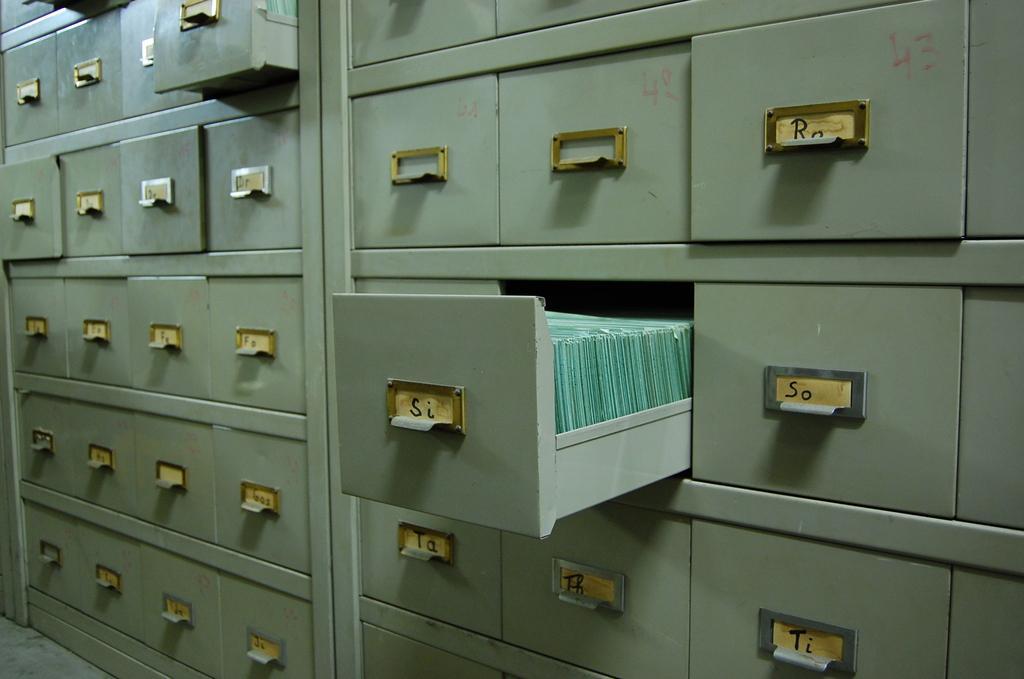How would you summarize this image in a sentence or two? In this image we can see there are lockers, in them few are opened. 